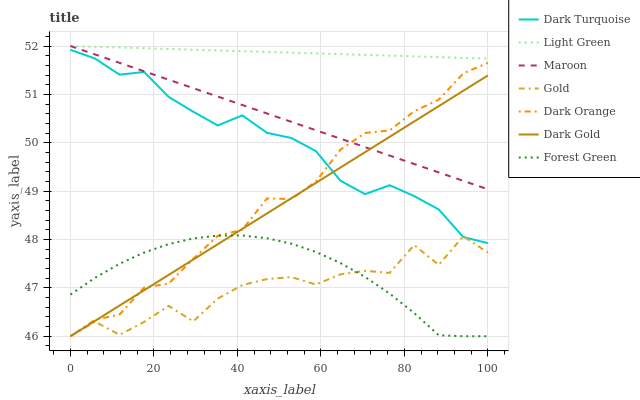Does Gold have the minimum area under the curve?
Answer yes or no. Yes. Does Light Green have the maximum area under the curve?
Answer yes or no. Yes. Does Dark Gold have the minimum area under the curve?
Answer yes or no. No. Does Dark Gold have the maximum area under the curve?
Answer yes or no. No. Is Maroon the smoothest?
Answer yes or no. Yes. Is Gold the roughest?
Answer yes or no. Yes. Is Dark Gold the smoothest?
Answer yes or no. No. Is Dark Gold the roughest?
Answer yes or no. No. Does Dark Turquoise have the lowest value?
Answer yes or no. No. Does Light Green have the highest value?
Answer yes or no. Yes. Does Dark Gold have the highest value?
Answer yes or no. No. Is Forest Green less than Maroon?
Answer yes or no. Yes. Is Light Green greater than Gold?
Answer yes or no. Yes. Does Dark Turquoise intersect Dark Gold?
Answer yes or no. Yes. Is Dark Turquoise less than Dark Gold?
Answer yes or no. No. Is Dark Turquoise greater than Dark Gold?
Answer yes or no. No. Does Forest Green intersect Maroon?
Answer yes or no. No. 